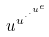<formula> <loc_0><loc_0><loc_500><loc_500>u ^ { u ^ { \cdot ^ { \cdot ^ { u ^ { e } } } } }</formula> 